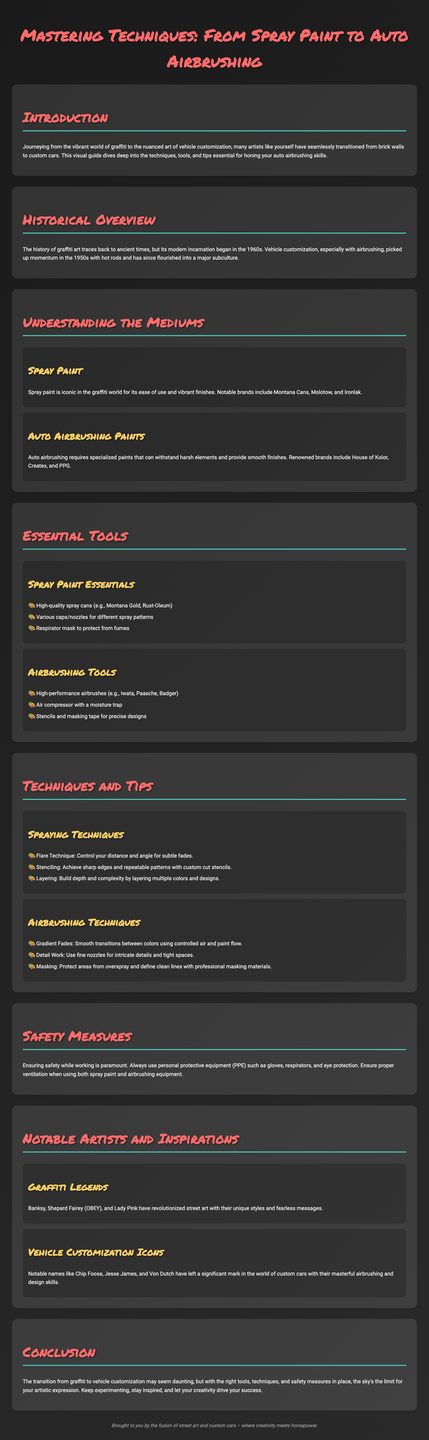What is the main focus of the infographic? The infographic focuses on mastering techniques from graffiti art to vehicle customization, emphasizing airbrushing.
Answer: vehicle customization Which spray paint brands are mentioned? The document lists notable spray paint brands in the section about understanding the mediums.
Answer: Montana Cans, Molotow, Ironlak What essential tool is required for airbrushing? The essential tools section specifies that high-performance airbrushes are crucial for airbrushing.
Answer: high-performance airbrushes Name one graffiti legend mentioned in the document. The section on notable artists cites famous graffiti artists for inspiration.
Answer: Banksy How many main sections are there in this infographic? The infographic is structured into several main sections, including introduction, historical overview, understanding the mediums, essential tools, techniques and tips, safety measures, notable artists, and conclusion.
Answer: seven What technique is used to achieve sharp edges in spraying? The techniques and tips section discusses stenciling as a method to achieve sharp edges in spray painting.
Answer: stenciling What safety equipment is recommended in the infographic? The safety measures section highlights the importance of personal protective equipment (PPE) for artists working with spray paints and airbrushes.
Answer: PPE What type of finishes are emphasized for auto airbrushing? The document discusses the requirement for specialized paints that can withstand harsh elements and provide smooth finishes, crucial for vehicle customization.
Answer: smooth finishes 